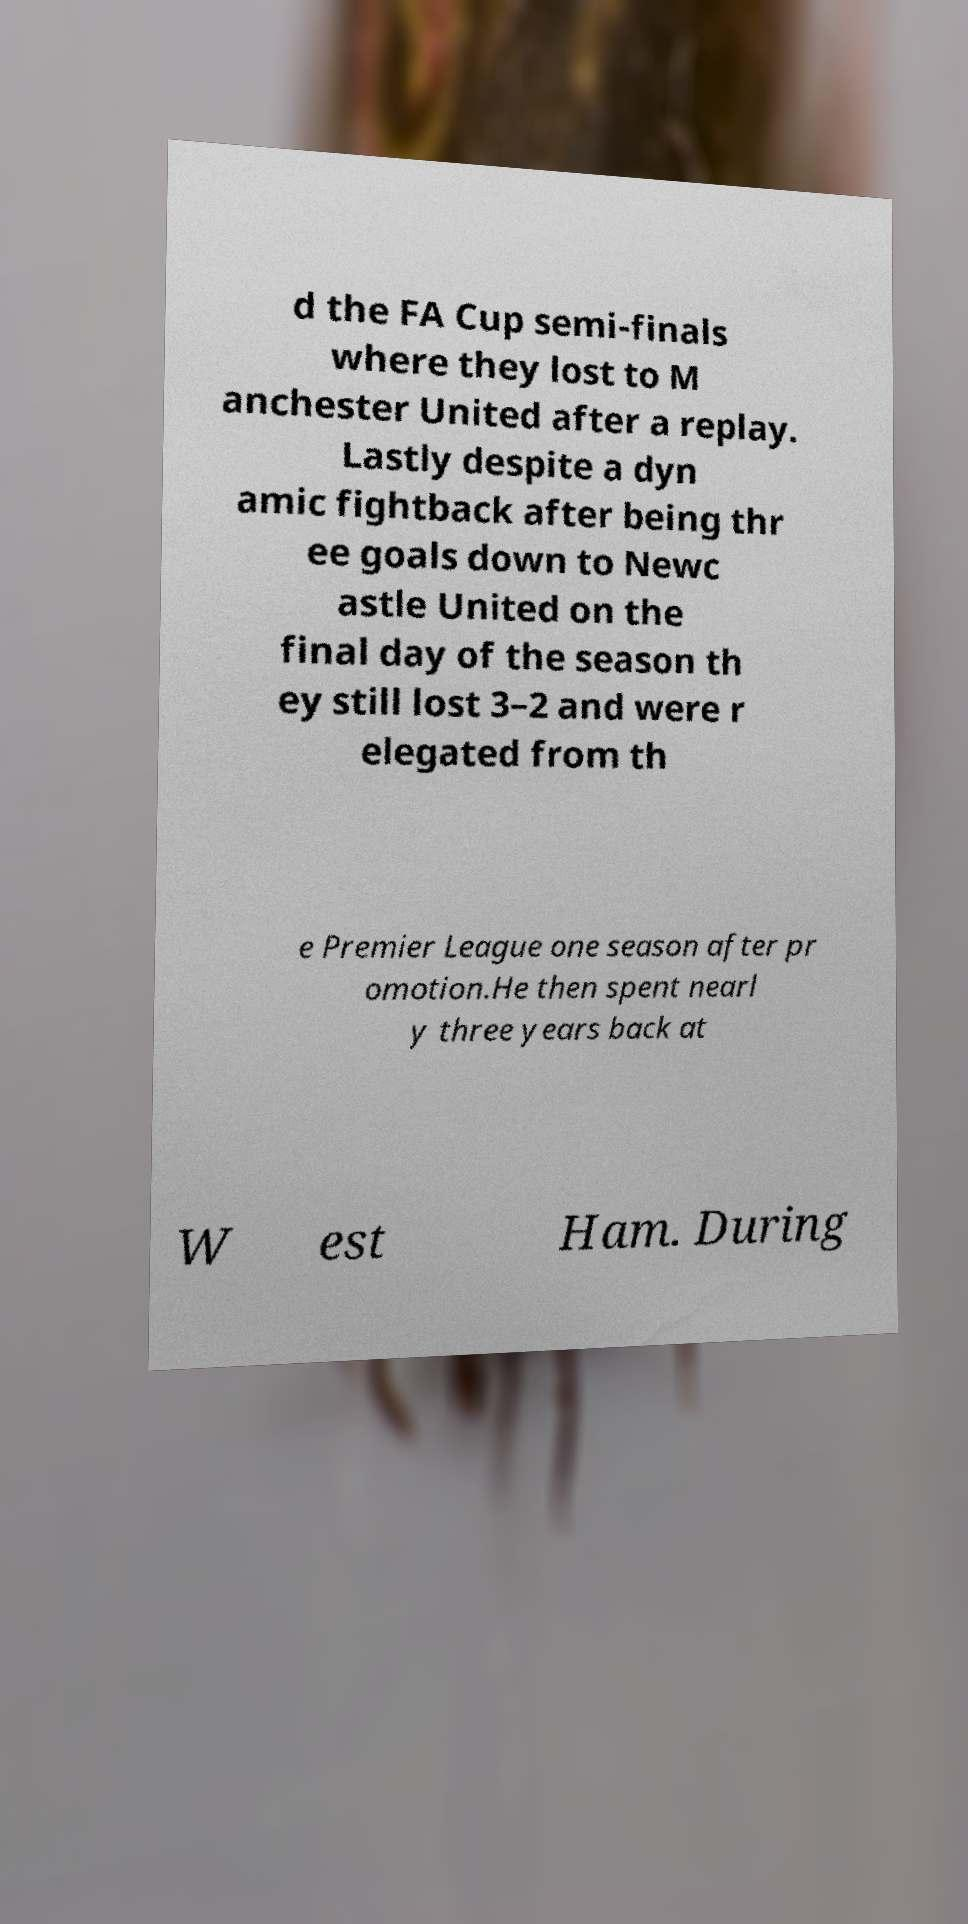Please identify and transcribe the text found in this image. d the FA Cup semi-finals where they lost to M anchester United after a replay. Lastly despite a dyn amic fightback after being thr ee goals down to Newc astle United on the final day of the season th ey still lost 3–2 and were r elegated from th e Premier League one season after pr omotion.He then spent nearl y three years back at W est Ham. During 